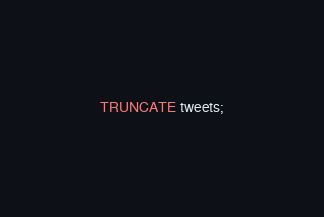Convert code to text. <code><loc_0><loc_0><loc_500><loc_500><_SQL_>TRUNCATE tweets;</code> 